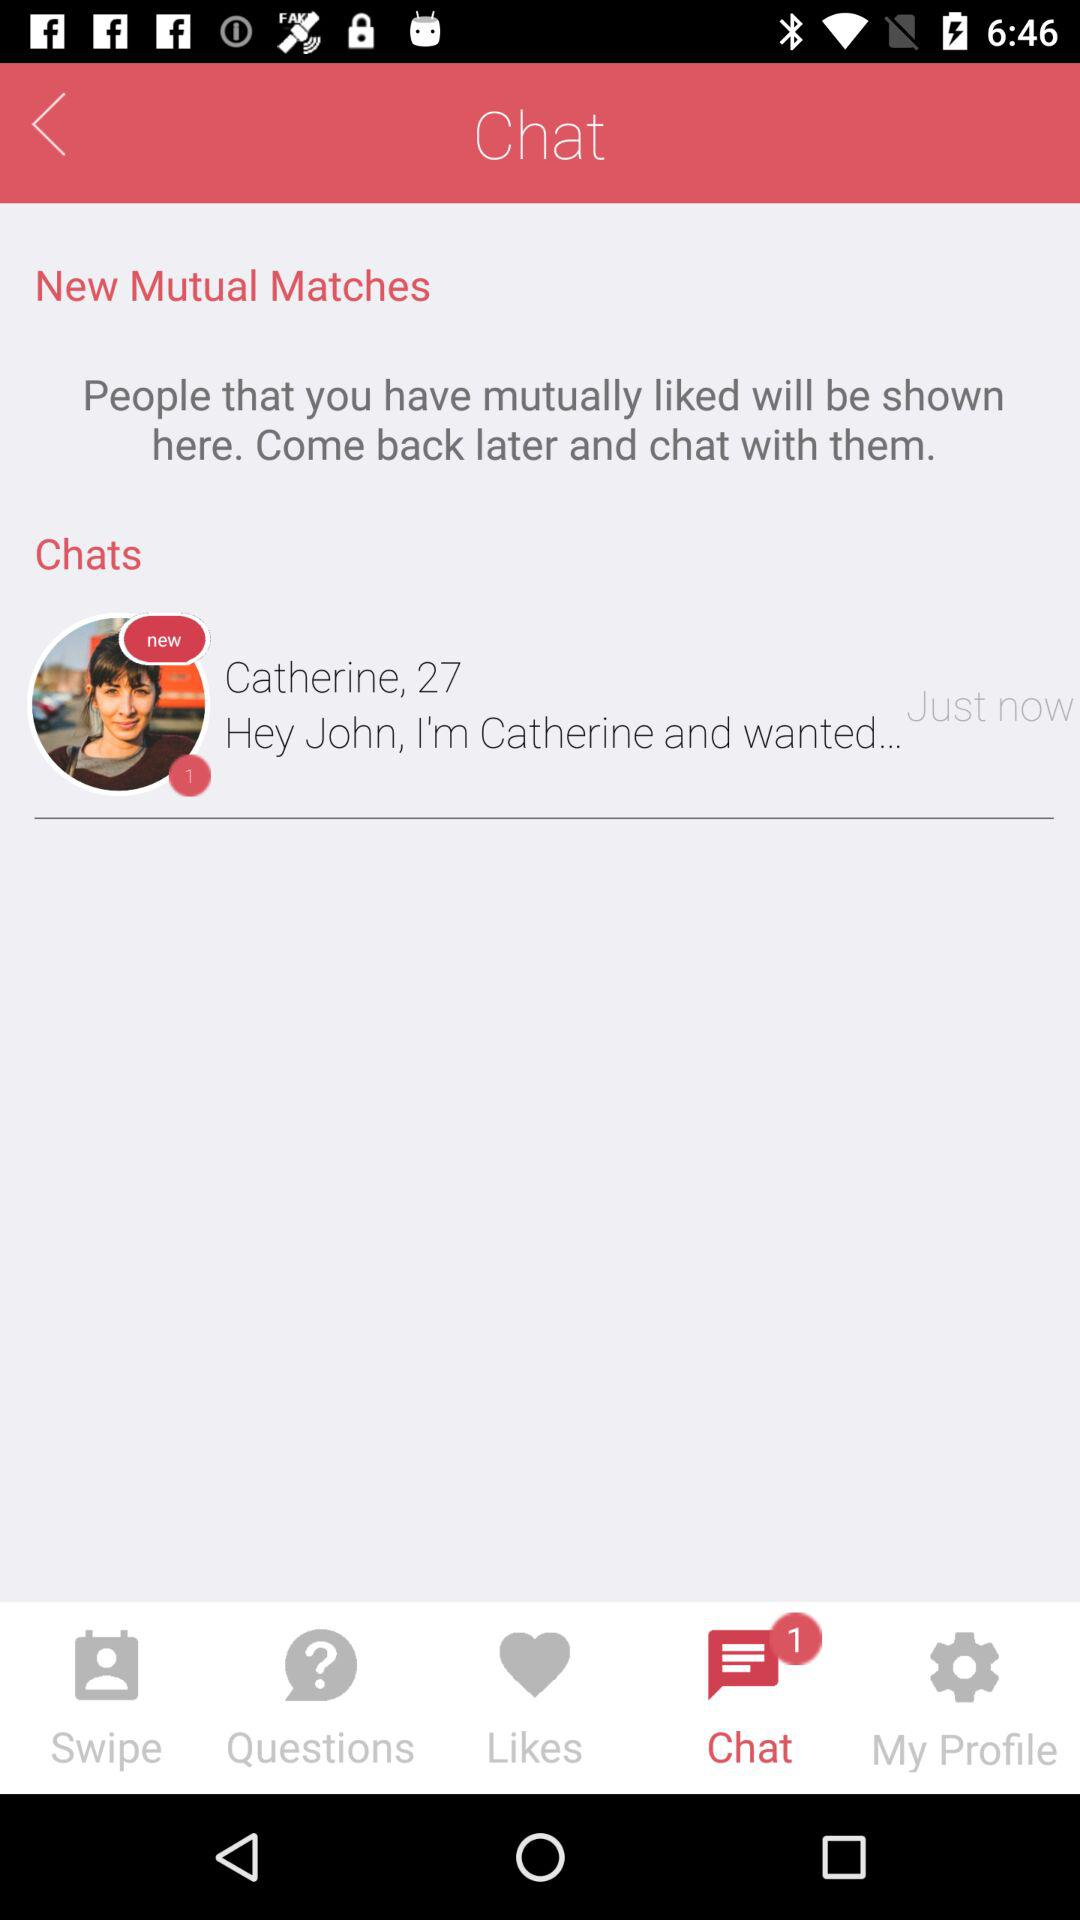What is the age of "Catherine"? The age is 27. 